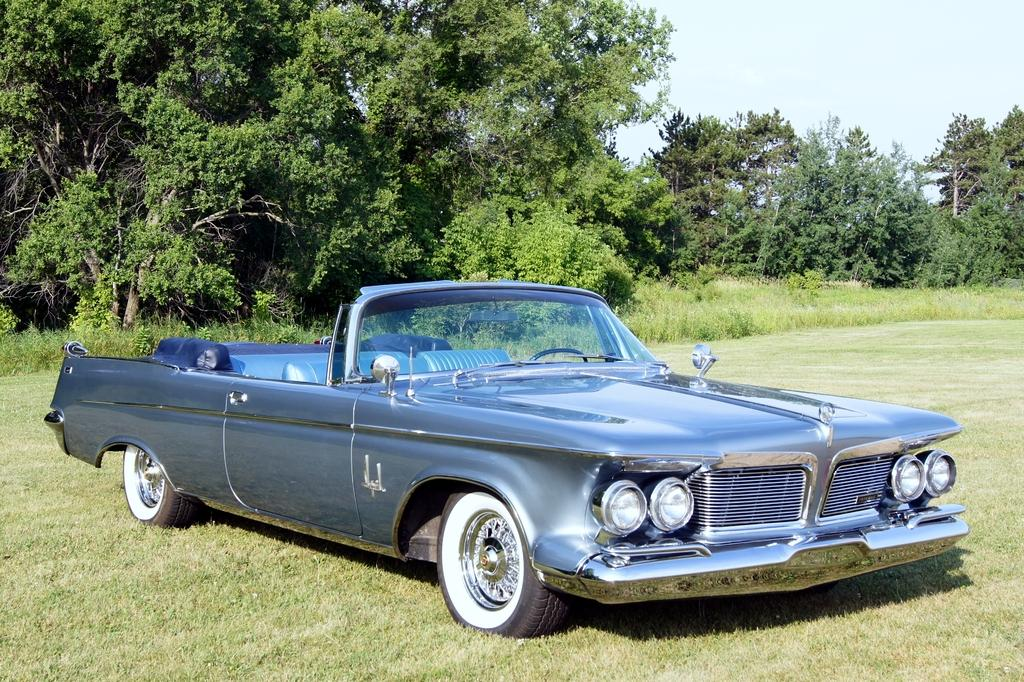What is the main subject in the middle of the image? There is a car in the middle of the image. What can be seen in the background of the image? There are trees in the background of the image. What is visible at the top of the image? The sky is visible at the top of the image. What type of flower is growing on the car in the image? There are no flowers present on the car in the image. How does the tramp interact with the car in the image? There is no tramp present in the image; it only features a car, trees, and the sky. 